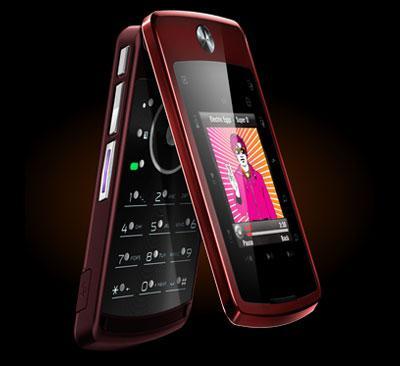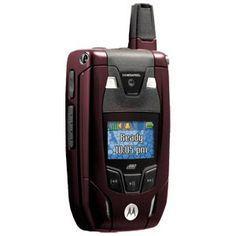The first image is the image on the left, the second image is the image on the right. For the images displayed, is the sentence "All of the phones are flip-phones; they can be physically unfolded to open them." factually correct? Answer yes or no. Yes. The first image is the image on the left, the second image is the image on the right. Examine the images to the left and right. Is the description "Every phone is a flip phone." accurate? Answer yes or no. Yes. 